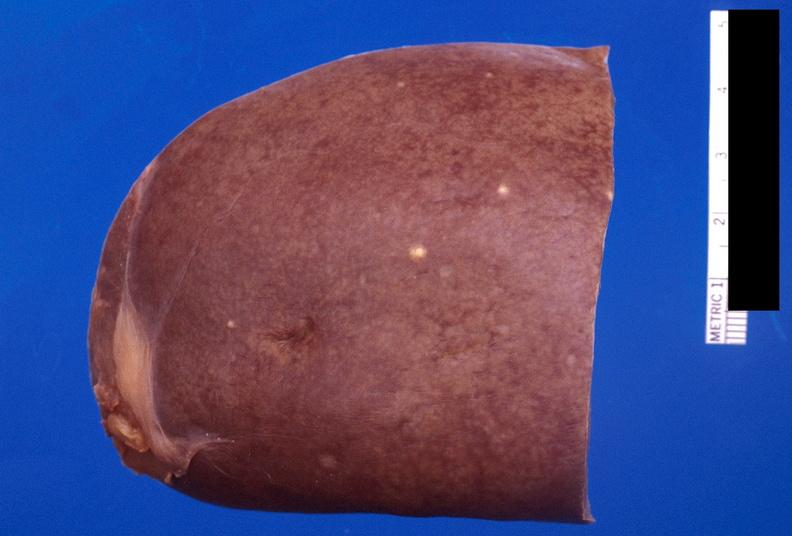s hematologic present?
Answer the question using a single word or phrase. Yes 